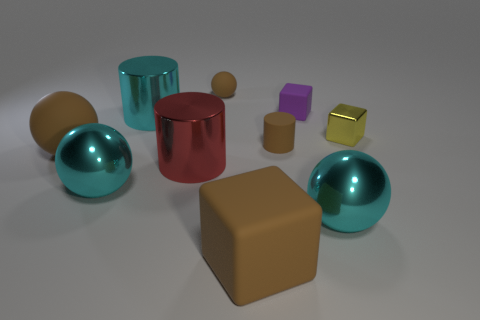Does the shiny sphere that is right of the cyan shiny cylinder have the same color as the tiny rubber cylinder?
Offer a very short reply. No. How many blocks are either yellow shiny objects or brown rubber objects?
Your answer should be compact. 2. What size is the cyan ball to the left of the big shiny ball to the right of the large shiny cylinder that is behind the small yellow thing?
Your answer should be compact. Large. There is a red metallic thing that is the same size as the brown matte block; what is its shape?
Provide a short and direct response. Cylinder. What is the shape of the tiny metallic object?
Your answer should be very brief. Cube. Does the block right of the purple object have the same material as the large brown ball?
Offer a terse response. No. There is a rubber ball behind the tiny metallic block to the right of the large brown ball; how big is it?
Offer a very short reply. Small. What color is the thing that is both behind the large cyan cylinder and left of the brown cylinder?
Your answer should be very brief. Brown. What is the material of the yellow cube that is the same size as the brown rubber cylinder?
Give a very brief answer. Metal. How many other things are made of the same material as the cyan cylinder?
Provide a short and direct response. 4. 